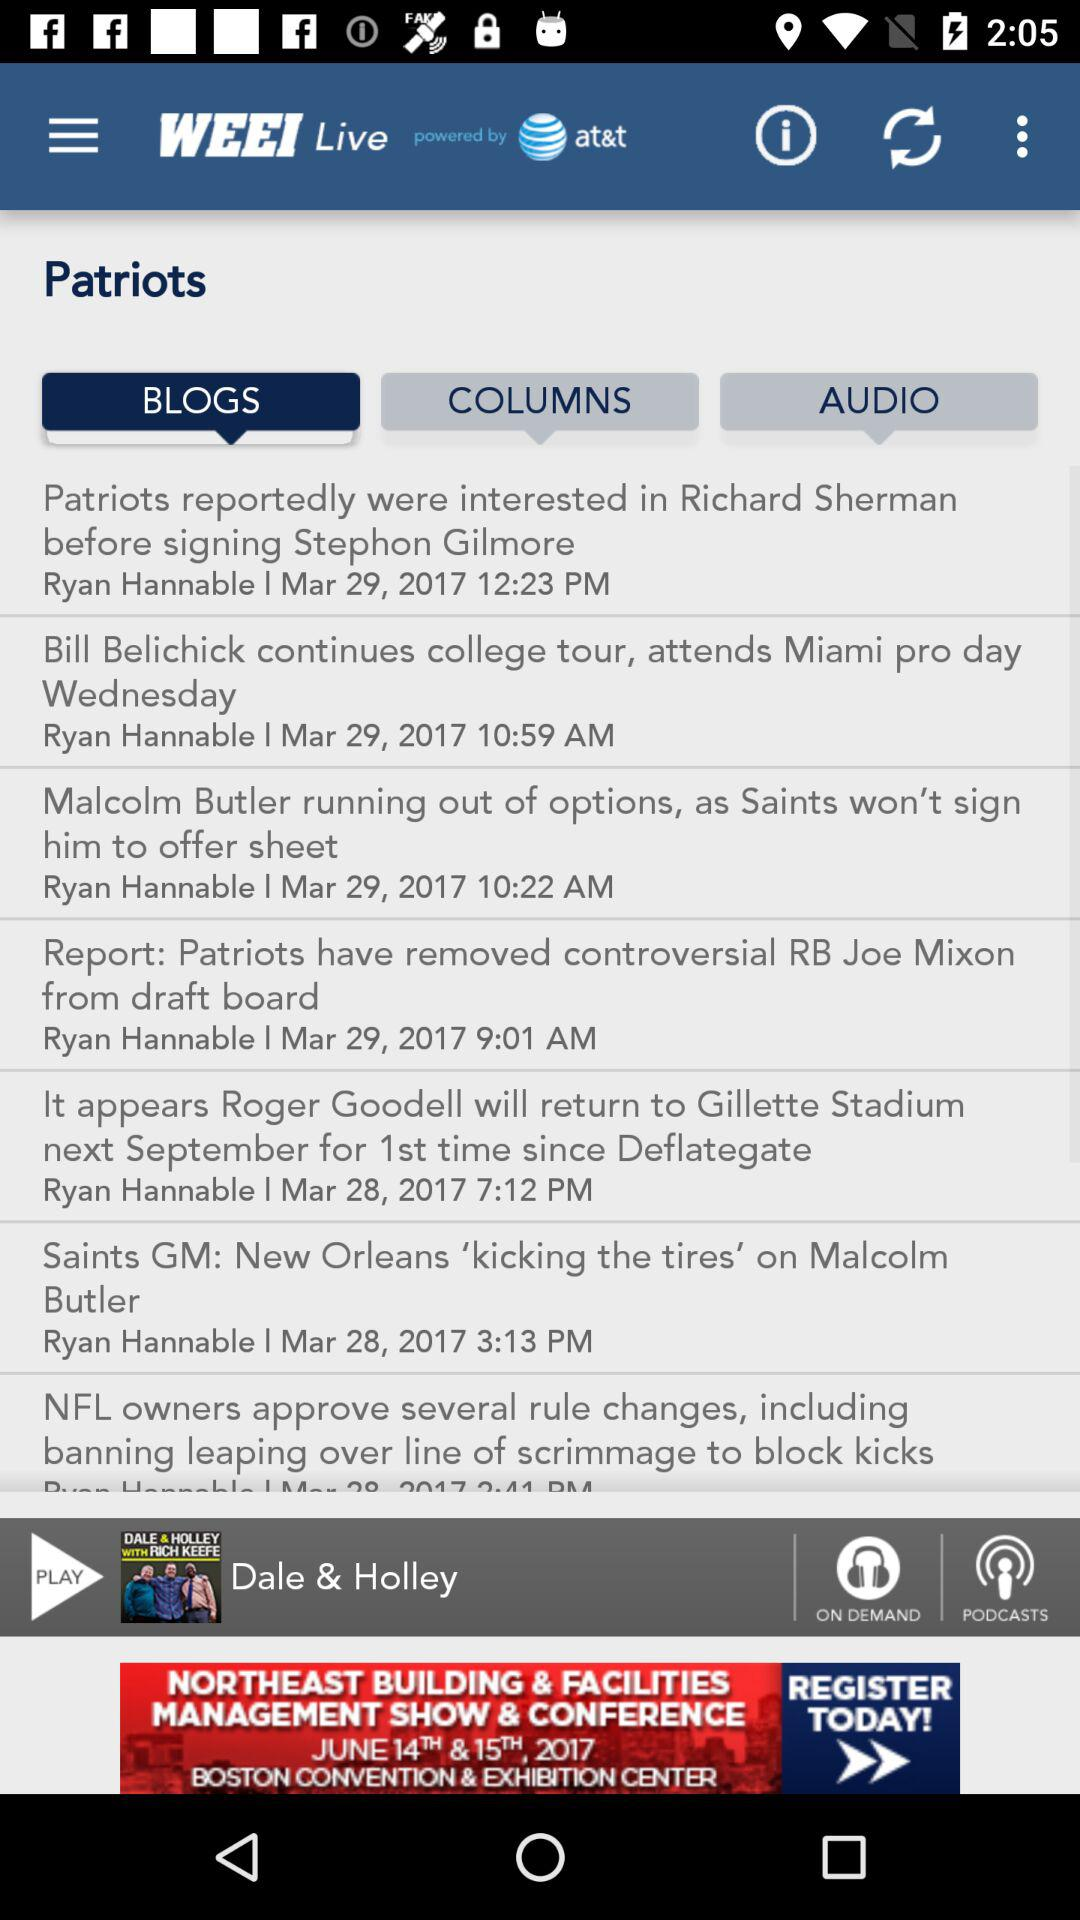How much does it cost to attend the 2-day management show and conference?
When the provided information is insufficient, respond with <no answer>. <no answer> 